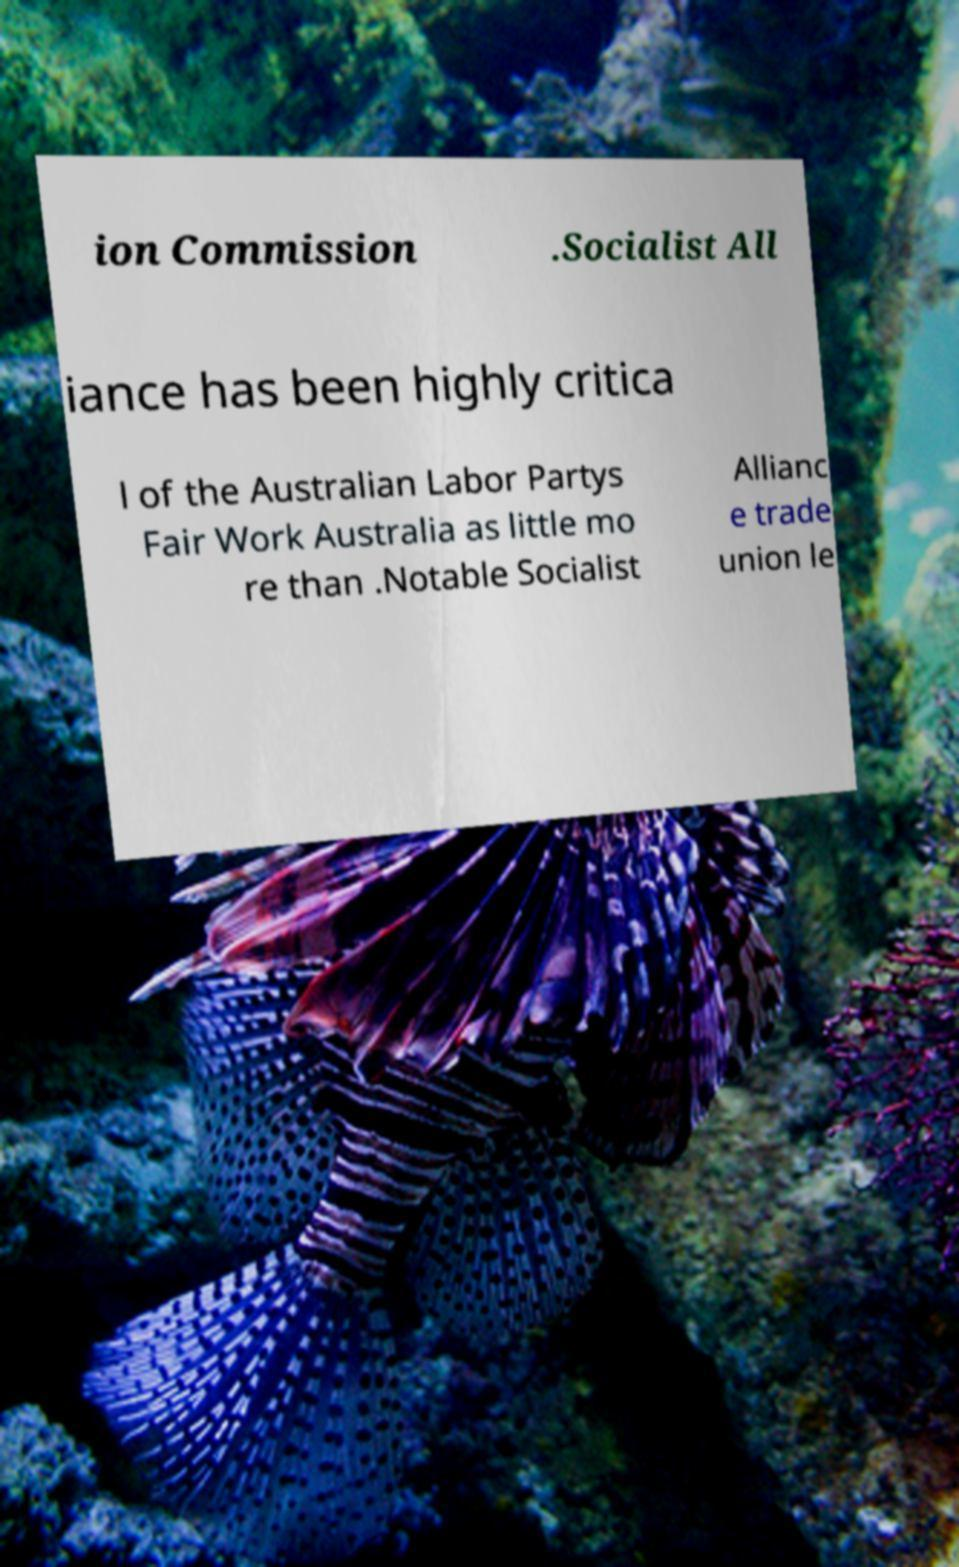There's text embedded in this image that I need extracted. Can you transcribe it verbatim? ion Commission .Socialist All iance has been highly critica l of the Australian Labor Partys Fair Work Australia as little mo re than .Notable Socialist Allianc e trade union le 